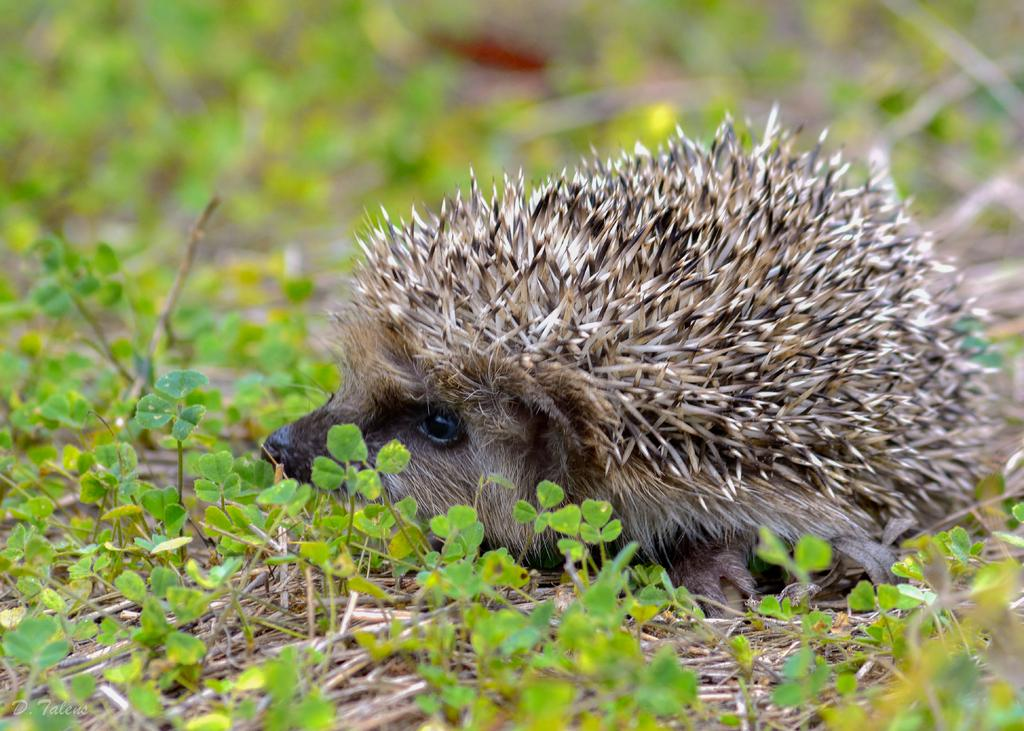What is the main subject in the center of the image? There is an animal in the center of the image. What type of vegetation can be seen at the bottom of the image? There is grass at the bottom of the image. What sense is the animal using to detect the iron in the image? There is no iron present in the image, and therefore the animal cannot use any sense to detect it. 